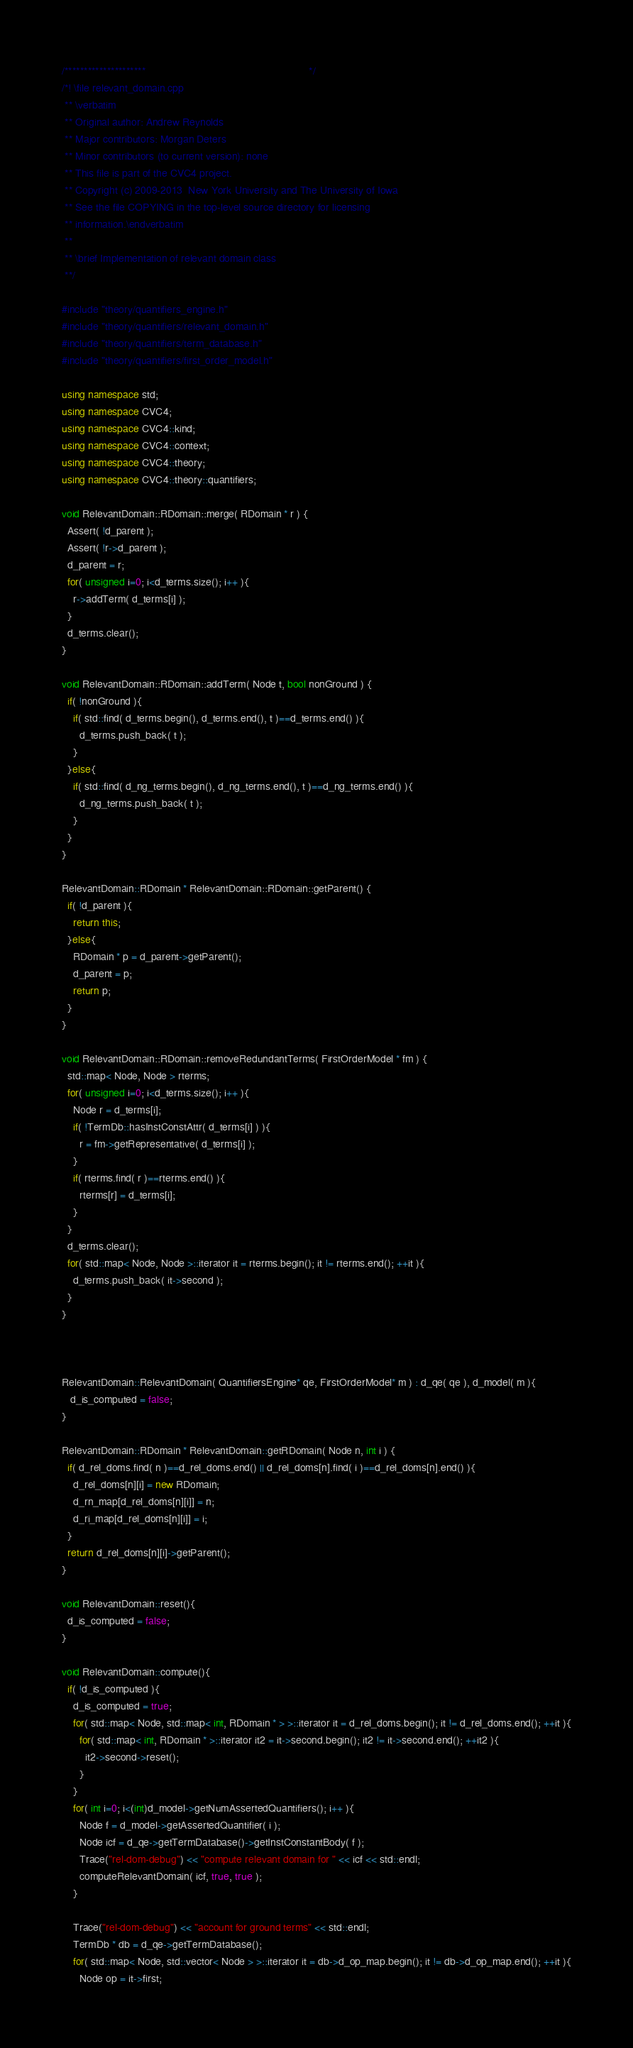<code> <loc_0><loc_0><loc_500><loc_500><_C++_>/*********************                                                        */
/*! \file relevant_domain.cpp
 ** \verbatim
 ** Original author: Andrew Reynolds
 ** Major contributors: Morgan Deters
 ** Minor contributors (to current version): none
 ** This file is part of the CVC4 project.
 ** Copyright (c) 2009-2013  New York University and The University of Iowa
 ** See the file COPYING in the top-level source directory for licensing
 ** information.\endverbatim
 **
 ** \brief Implementation of relevant domain class
 **/

#include "theory/quantifiers_engine.h"
#include "theory/quantifiers/relevant_domain.h"
#include "theory/quantifiers/term_database.h"
#include "theory/quantifiers/first_order_model.h"

using namespace std;
using namespace CVC4;
using namespace CVC4::kind;
using namespace CVC4::context;
using namespace CVC4::theory;
using namespace CVC4::theory::quantifiers;

void RelevantDomain::RDomain::merge( RDomain * r ) {
  Assert( !d_parent );
  Assert( !r->d_parent );
  d_parent = r;
  for( unsigned i=0; i<d_terms.size(); i++ ){
    r->addTerm( d_terms[i] );
  }
  d_terms.clear();
}

void RelevantDomain::RDomain::addTerm( Node t, bool nonGround ) {
  if( !nonGround ){
    if( std::find( d_terms.begin(), d_terms.end(), t )==d_terms.end() ){
      d_terms.push_back( t );
    }
  }else{
    if( std::find( d_ng_terms.begin(), d_ng_terms.end(), t )==d_ng_terms.end() ){
      d_ng_terms.push_back( t );
    }
  }
}

RelevantDomain::RDomain * RelevantDomain::RDomain::getParent() {
  if( !d_parent ){
    return this;
  }else{
    RDomain * p = d_parent->getParent();
    d_parent = p;
    return p;
  }
}

void RelevantDomain::RDomain::removeRedundantTerms( FirstOrderModel * fm ) {
  std::map< Node, Node > rterms;
  for( unsigned i=0; i<d_terms.size(); i++ ){
    Node r = d_terms[i];
    if( !TermDb::hasInstConstAttr( d_terms[i] ) ){
      r = fm->getRepresentative( d_terms[i] );
    }
    if( rterms.find( r )==rterms.end() ){
      rterms[r] = d_terms[i];
    }
  }
  d_terms.clear();
  for( std::map< Node, Node >::iterator it = rterms.begin(); it != rterms.end(); ++it ){
    d_terms.push_back( it->second );
  }
}



RelevantDomain::RelevantDomain( QuantifiersEngine* qe, FirstOrderModel* m ) : d_qe( qe ), d_model( m ){
   d_is_computed = false;
}

RelevantDomain::RDomain * RelevantDomain::getRDomain( Node n, int i ) {
  if( d_rel_doms.find( n )==d_rel_doms.end() || d_rel_doms[n].find( i )==d_rel_doms[n].end() ){
    d_rel_doms[n][i] = new RDomain;
    d_rn_map[d_rel_doms[n][i]] = n;
    d_ri_map[d_rel_doms[n][i]] = i;
  }
  return d_rel_doms[n][i]->getParent();
}

void RelevantDomain::reset(){
  d_is_computed = false;
}

void RelevantDomain::compute(){
  if( !d_is_computed ){
    d_is_computed = true;
    for( std::map< Node, std::map< int, RDomain * > >::iterator it = d_rel_doms.begin(); it != d_rel_doms.end(); ++it ){
      for( std::map< int, RDomain * >::iterator it2 = it->second.begin(); it2 != it->second.end(); ++it2 ){
        it2->second->reset();
      }
    }
    for( int i=0; i<(int)d_model->getNumAssertedQuantifiers(); i++ ){
      Node f = d_model->getAssertedQuantifier( i );
      Node icf = d_qe->getTermDatabase()->getInstConstantBody( f );
      Trace("rel-dom-debug") << "compute relevant domain for " << icf << std::endl;
      computeRelevantDomain( icf, true, true );
    }

    Trace("rel-dom-debug") << "account for ground terms" << std::endl;
    TermDb * db = d_qe->getTermDatabase();
    for( std::map< Node, std::vector< Node > >::iterator it = db->d_op_map.begin(); it != db->d_op_map.end(); ++it ){
      Node op = it->first;</code> 